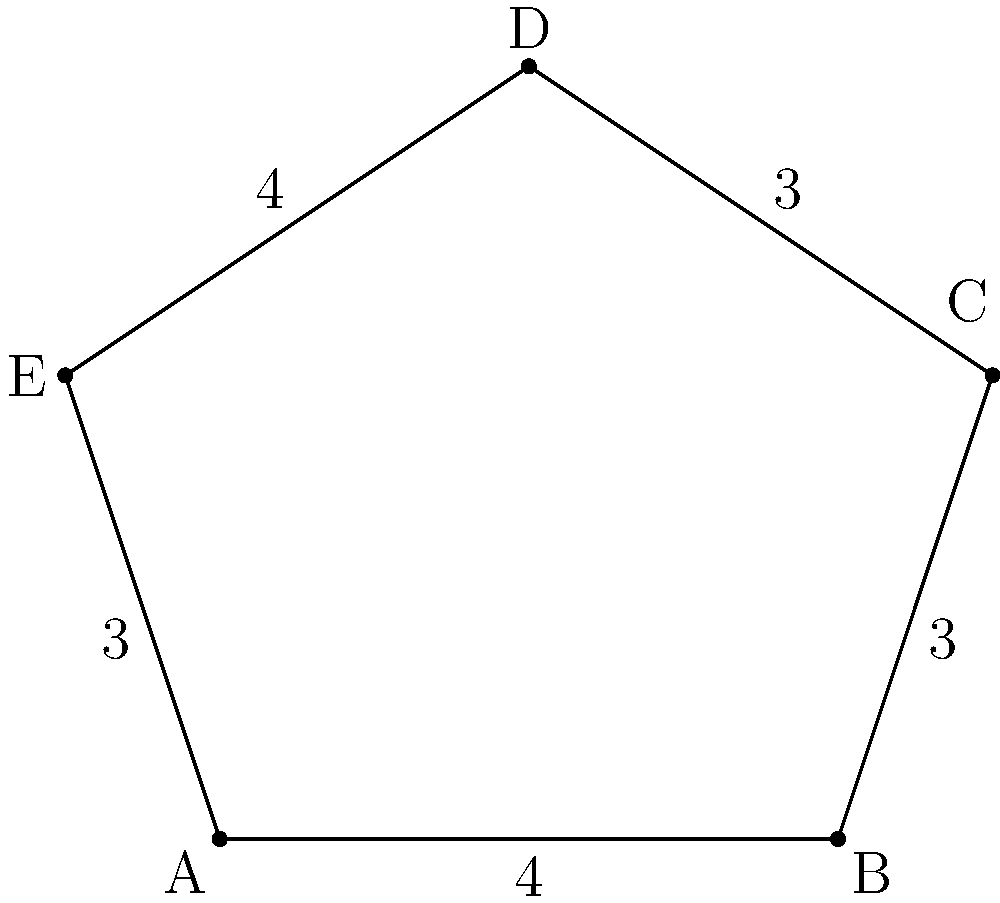The cross-section of a pineapple leaf fiber is represented by the polygon ABCDE shown in the figure. Given that AB = 4 units, BC = 3 units, CD = 3 units, DE = 4 units, and EA = 3 units, calculate the perimeter of the polygon. To calculate the perimeter of the polygon, we need to sum up the lengths of all its sides. Let's go through this step-by-step:

1) The lengths of the sides are given:
   AB = 4 units
   BC = 3 units
   CD = 3 units
   DE = 4 units
   EA = 3 units

2) The perimeter is the sum of all these lengths:
   
   Perimeter = AB + BC + CD + DE + EA
   
3) Substituting the values:
   
   Perimeter = 4 + 3 + 3 + 4 + 3

4) Calculating the sum:
   
   Perimeter = 17 units

Therefore, the perimeter of the polygon representing the pineapple leaf fiber's cross-section is 17 units.
Answer: 17 units 